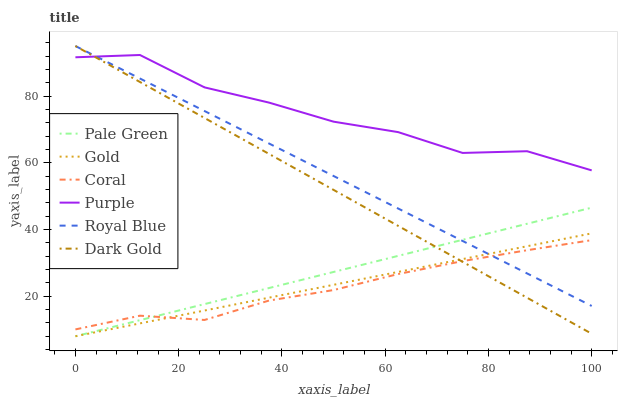Does Coral have the minimum area under the curve?
Answer yes or no. Yes. Does Purple have the maximum area under the curve?
Answer yes or no. Yes. Does Dark Gold have the minimum area under the curve?
Answer yes or no. No. Does Dark Gold have the maximum area under the curve?
Answer yes or no. No. Is Gold the smoothest?
Answer yes or no. Yes. Is Purple the roughest?
Answer yes or no. Yes. Is Dark Gold the smoothest?
Answer yes or no. No. Is Dark Gold the roughest?
Answer yes or no. No. Does Gold have the lowest value?
Answer yes or no. Yes. Does Dark Gold have the lowest value?
Answer yes or no. No. Does Royal Blue have the highest value?
Answer yes or no. Yes. Does Purple have the highest value?
Answer yes or no. No. Is Coral less than Purple?
Answer yes or no. Yes. Is Purple greater than Pale Green?
Answer yes or no. Yes. Does Coral intersect Pale Green?
Answer yes or no. Yes. Is Coral less than Pale Green?
Answer yes or no. No. Is Coral greater than Pale Green?
Answer yes or no. No. Does Coral intersect Purple?
Answer yes or no. No. 